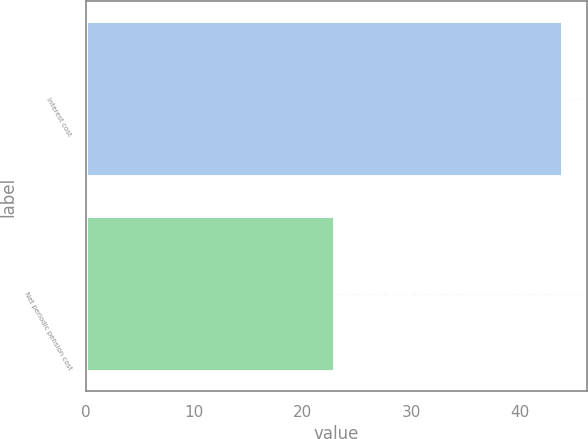<chart> <loc_0><loc_0><loc_500><loc_500><bar_chart><fcel>Interest cost<fcel>Net periodic pension cost<nl><fcel>44<fcel>23<nl></chart> 